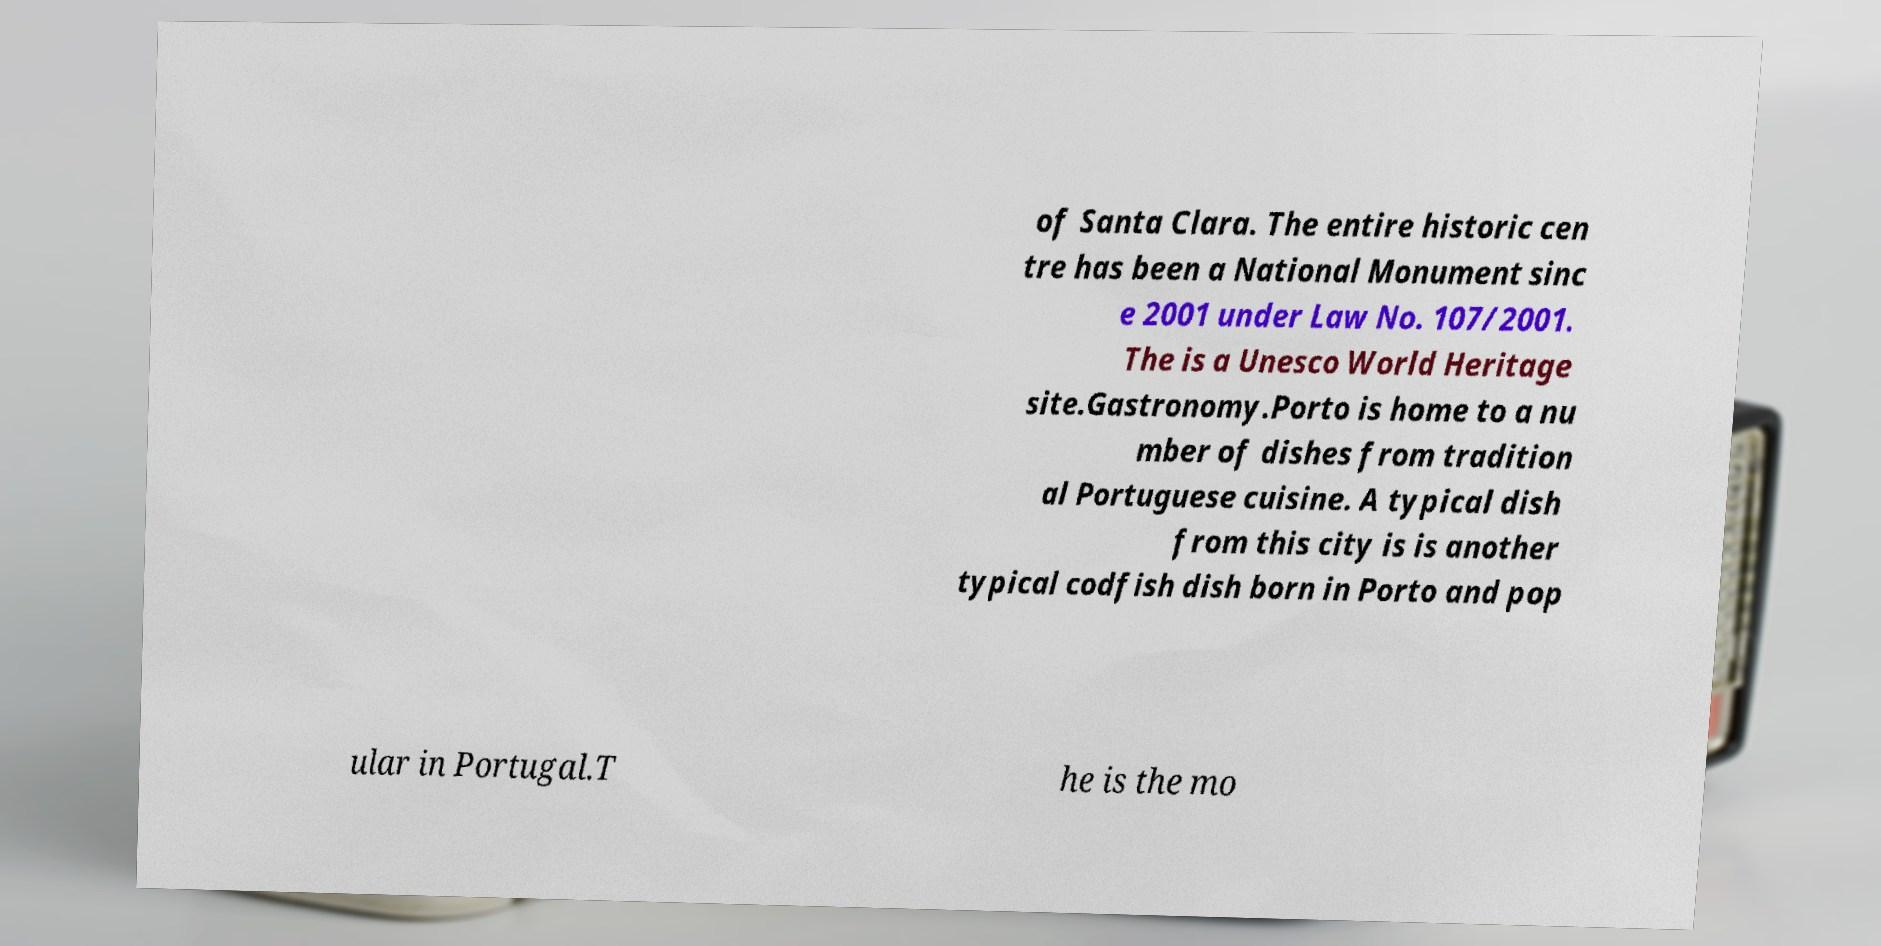Please read and relay the text visible in this image. What does it say? of Santa Clara. The entire historic cen tre has been a National Monument sinc e 2001 under Law No. 107/2001. The is a Unesco World Heritage site.Gastronomy.Porto is home to a nu mber of dishes from tradition al Portuguese cuisine. A typical dish from this city is is another typical codfish dish born in Porto and pop ular in Portugal.T he is the mo 